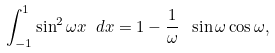Convert formula to latex. <formula><loc_0><loc_0><loc_500><loc_500>\int _ { - 1 } ^ { 1 } \sin ^ { 2 } \omega x \ d x = 1 - \frac { 1 } { \omega } \ \sin \omega \cos \omega ,</formula> 